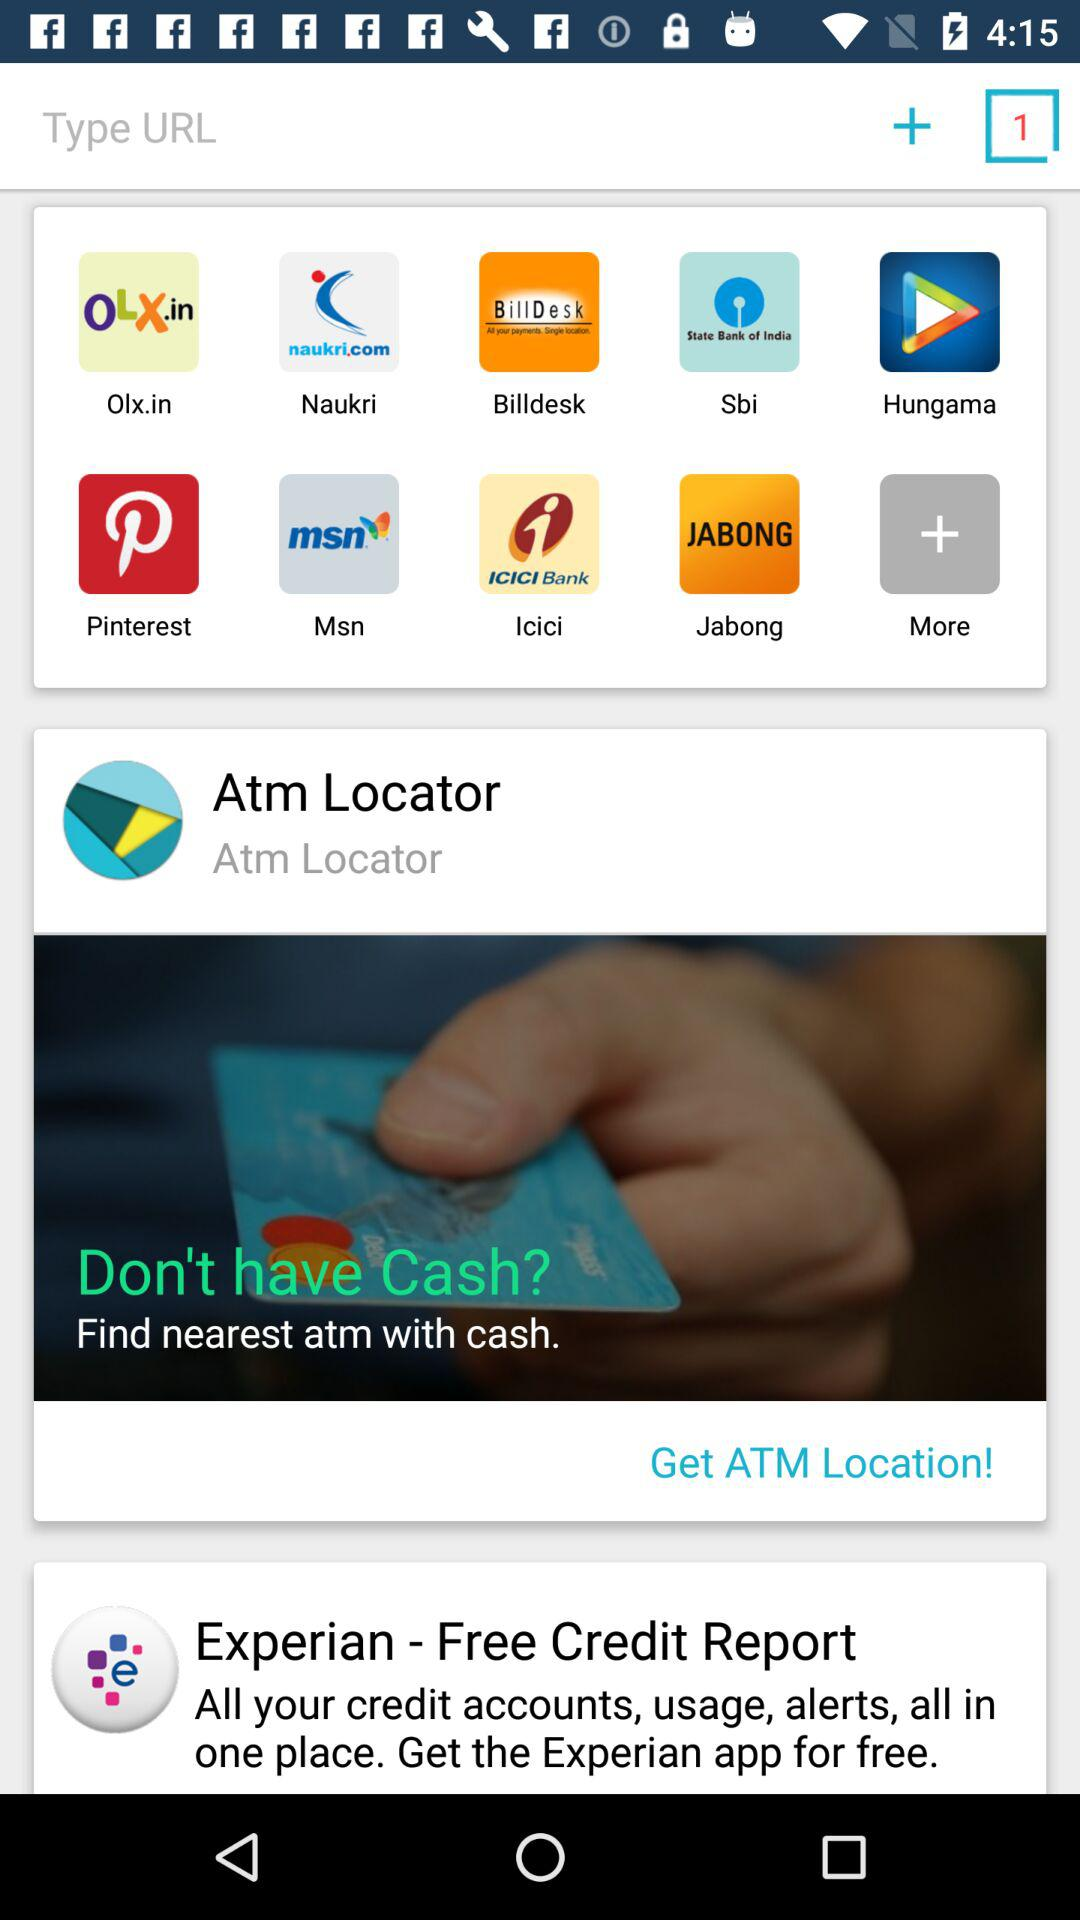How many tabs are open? There is 1 tab open. 